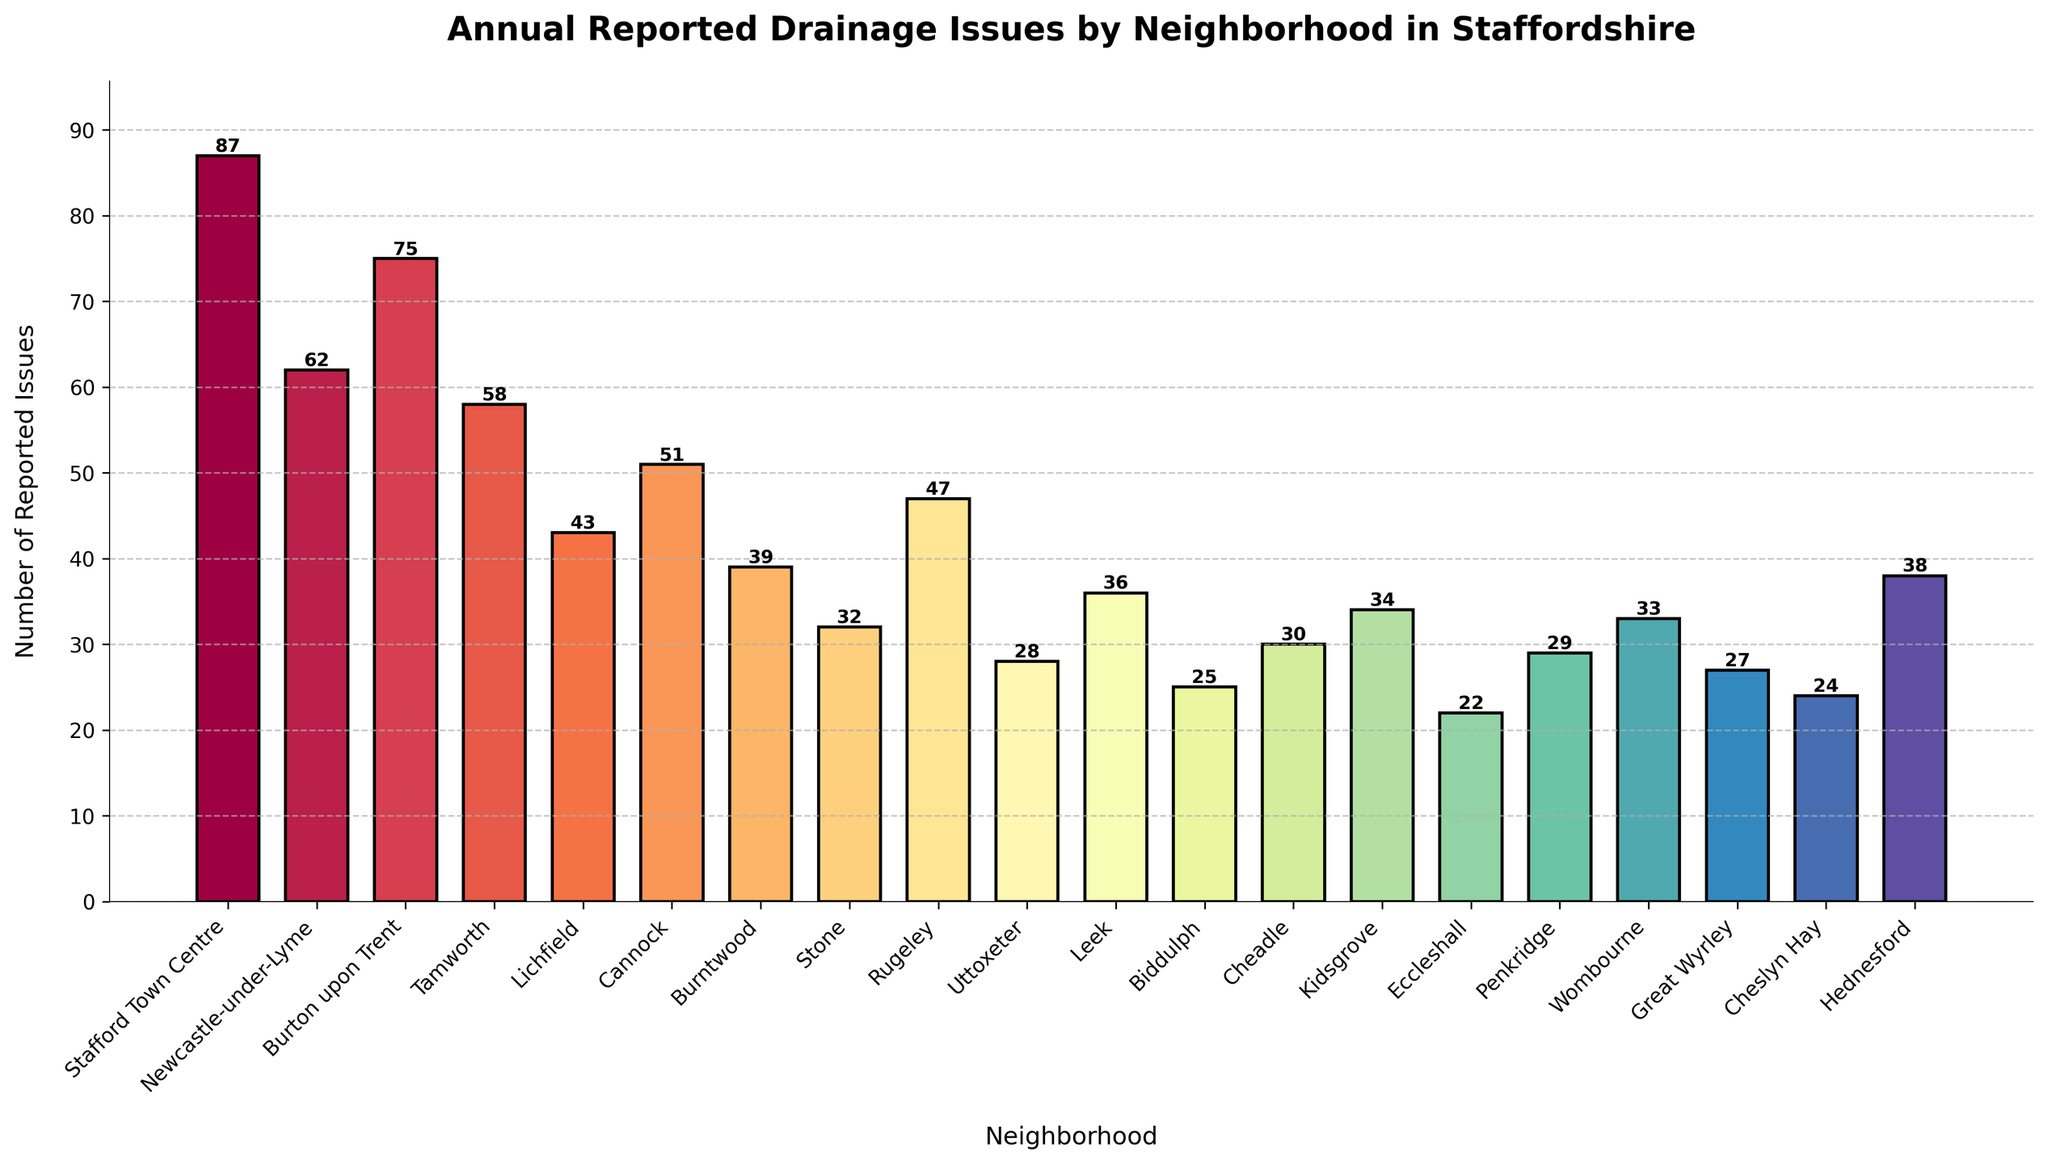Which neighborhood has the highest number of reported drainage issues? The tallest bar represents the neighborhood with the highest number of reported drainage issues. By inspecting the heights of the bars, Stafford Town Centre has the tallest bar with 87 reported issues.
Answer: Stafford Town Centre What is the total number of reported drainage issues for Cannock and Stone combined? To find the total, add the number of reported drainage issues for Cannock (51) and Stone (32). 51 + 32 = 83.
Answer: 83 Which neighborhood has fewer reported drainage issues, Lichfield or Hednesford? Compare the heights of the bars for Lichfield and Hednesford. Lichfield has 43 and Hednesford has 38. Since 38 is less than 43, Hednesford has fewer issues.
Answer: Hednesford What is the average number of reported drainage issues across all neighborhoods? Sum all the reported issues: 87 + 62 + 75 + 58 + 43 + 51 + 39 + 32 + 47 + 28 + 36 + 25 + 30 + 34 + 22 + 29 + 33 + 27 + 24 + 38 = 789. There are 19 neighborhoods, so divide the total by 19. Average = 789/19 ≈ 41.53.
Answer: 41.53 By how much does Stafford Town Centre exceed Burton upon Trent in reported drainage issues? Subtract the issues in Burton upon Trent (75) from the issues in Stafford Town Centre (87). 87 - 75 = 12.
Answer: 12 Rank the neighborhoods with the top three highest reported drainage issues. Identify the bars with the greatest heights. The top three are: Stafford Town Centre (87), Burton upon Trent (75), and Newcastle-under-Lyme (62) in descending order of reported drainage issues.
Answer: Stafford Town Centre, Burton upon Trent, Newcastle-under-Lyme Is the number of reported drainage issues in Kidsgrove closer to those in Cheadle or in Hednesford? Kidsgrove has 34 issues, Cheadle has 30, and Hednesford has 38. The difference for Kidsgrove is 34 - 30 = 4 (Cheadle) and 38 - 34 = 4 (Hednesford). Since both differences are equal, it's equally close to both.
Answer: Equally close to Cheadle and Hednesford What is the difference in reported drainage issues between the neighborhood with the most issues and the neighborhood with the least? Subtract the least issues in Eccleshall (22) from the most issues in Stafford Town Centre (87). 87 - 22 = 65.
Answer: 65 How many neighborhoods have reported issues greater than 40? Count the neighborhoods with bars higher than 40: Stafford Town Centre (87), Newcastle-under-Lyme (62), Burton upon Trent (75), Tamworth (58), Lichfield (43), Cannock (51), Rugeley (47), and Hednesford (38). This gives us 7 neighborhoods.
Answer: 7 